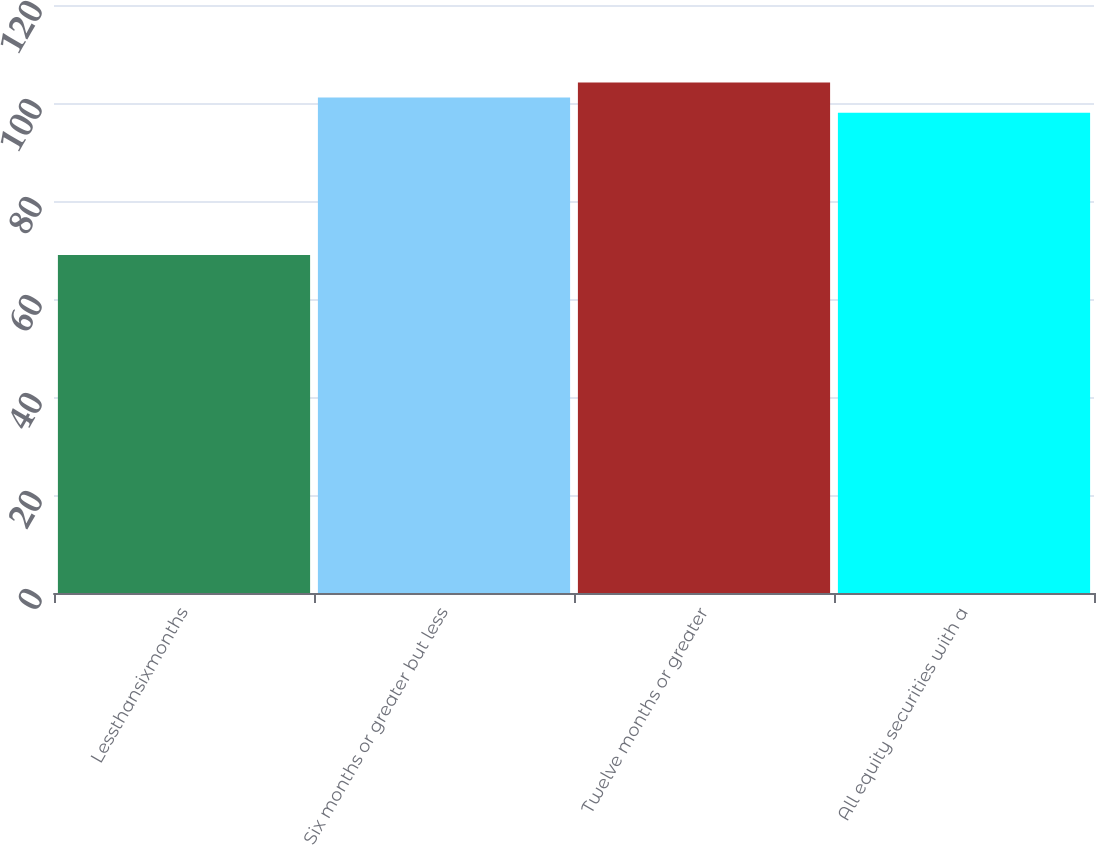Convert chart. <chart><loc_0><loc_0><loc_500><loc_500><bar_chart><fcel>Lessthansixmonths<fcel>Six months or greater but less<fcel>Twelve months or greater<fcel>All equity securities with a<nl><fcel>69<fcel>101.1<fcel>104.2<fcel>98<nl></chart> 